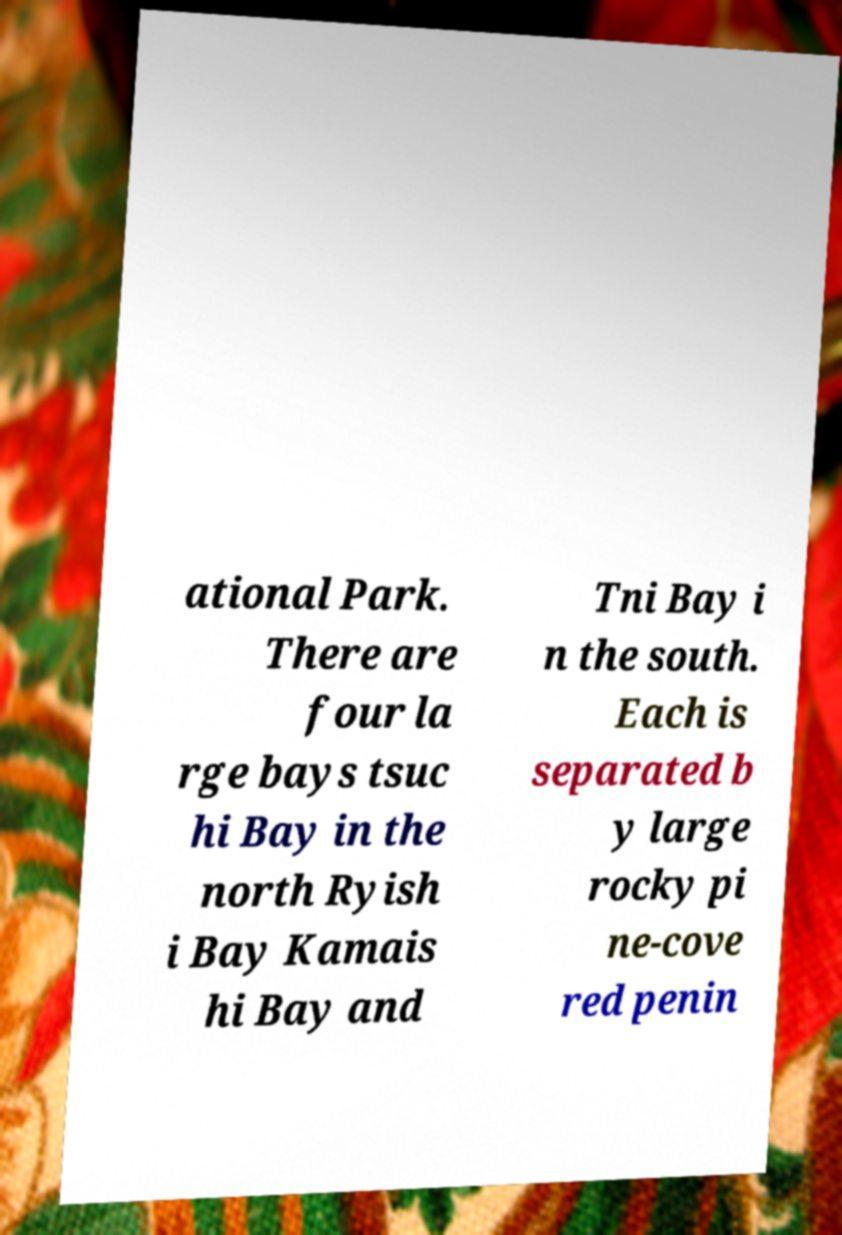Could you extract and type out the text from this image? ational Park. There are four la rge bays tsuc hi Bay in the north Ryish i Bay Kamais hi Bay and Tni Bay i n the south. Each is separated b y large rocky pi ne-cove red penin 